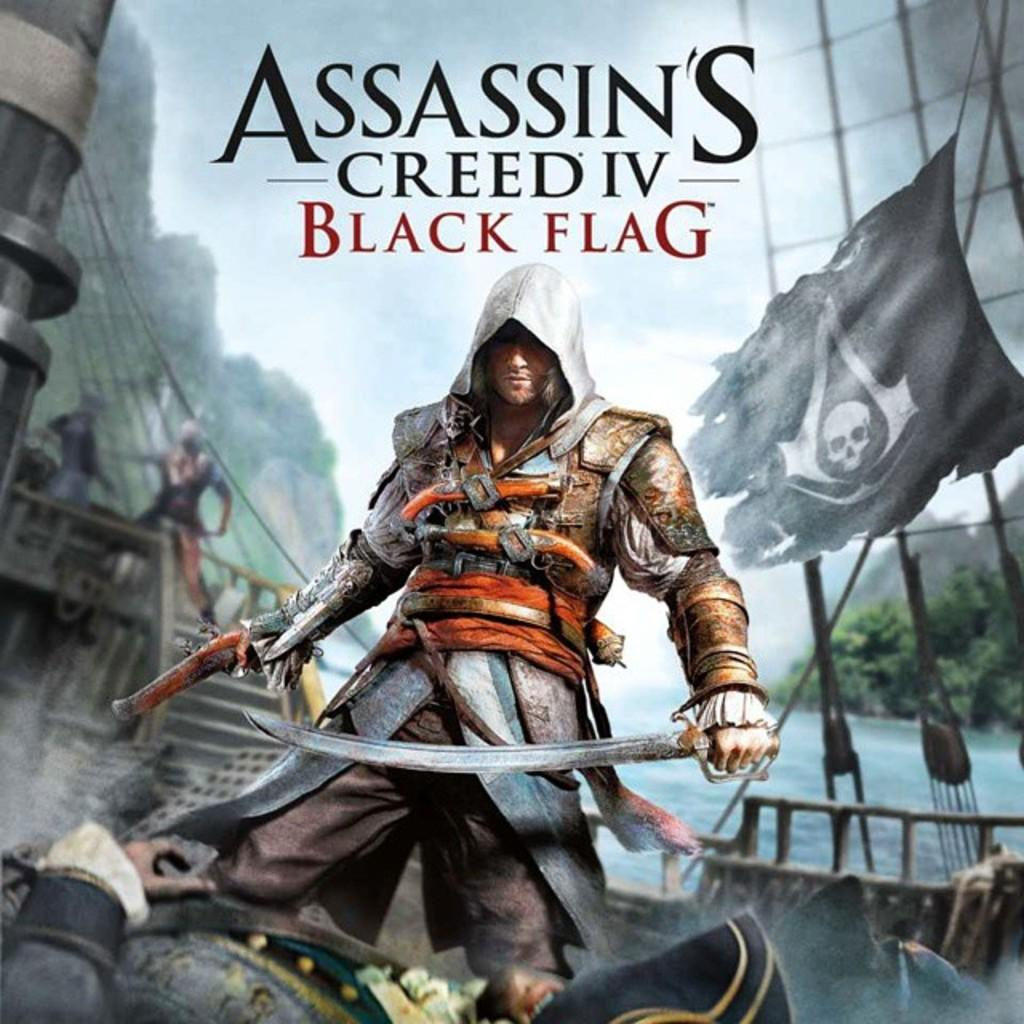Provide a one-sentence caption for the provided image. An advertisement of Assassin's Creed IV Black Flag features a man with a sword. 